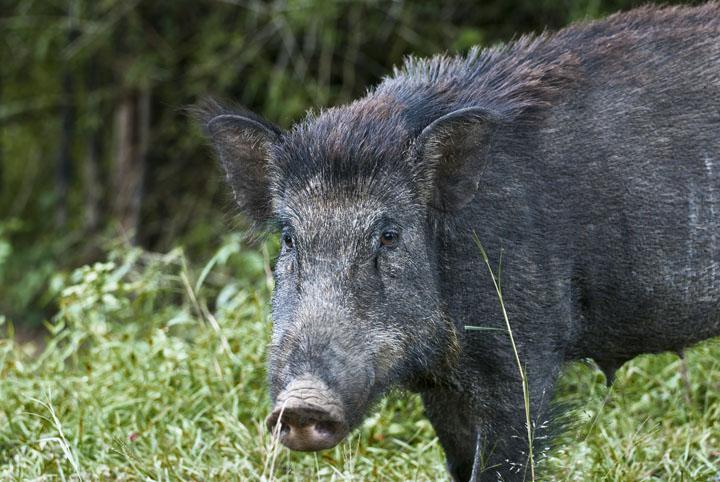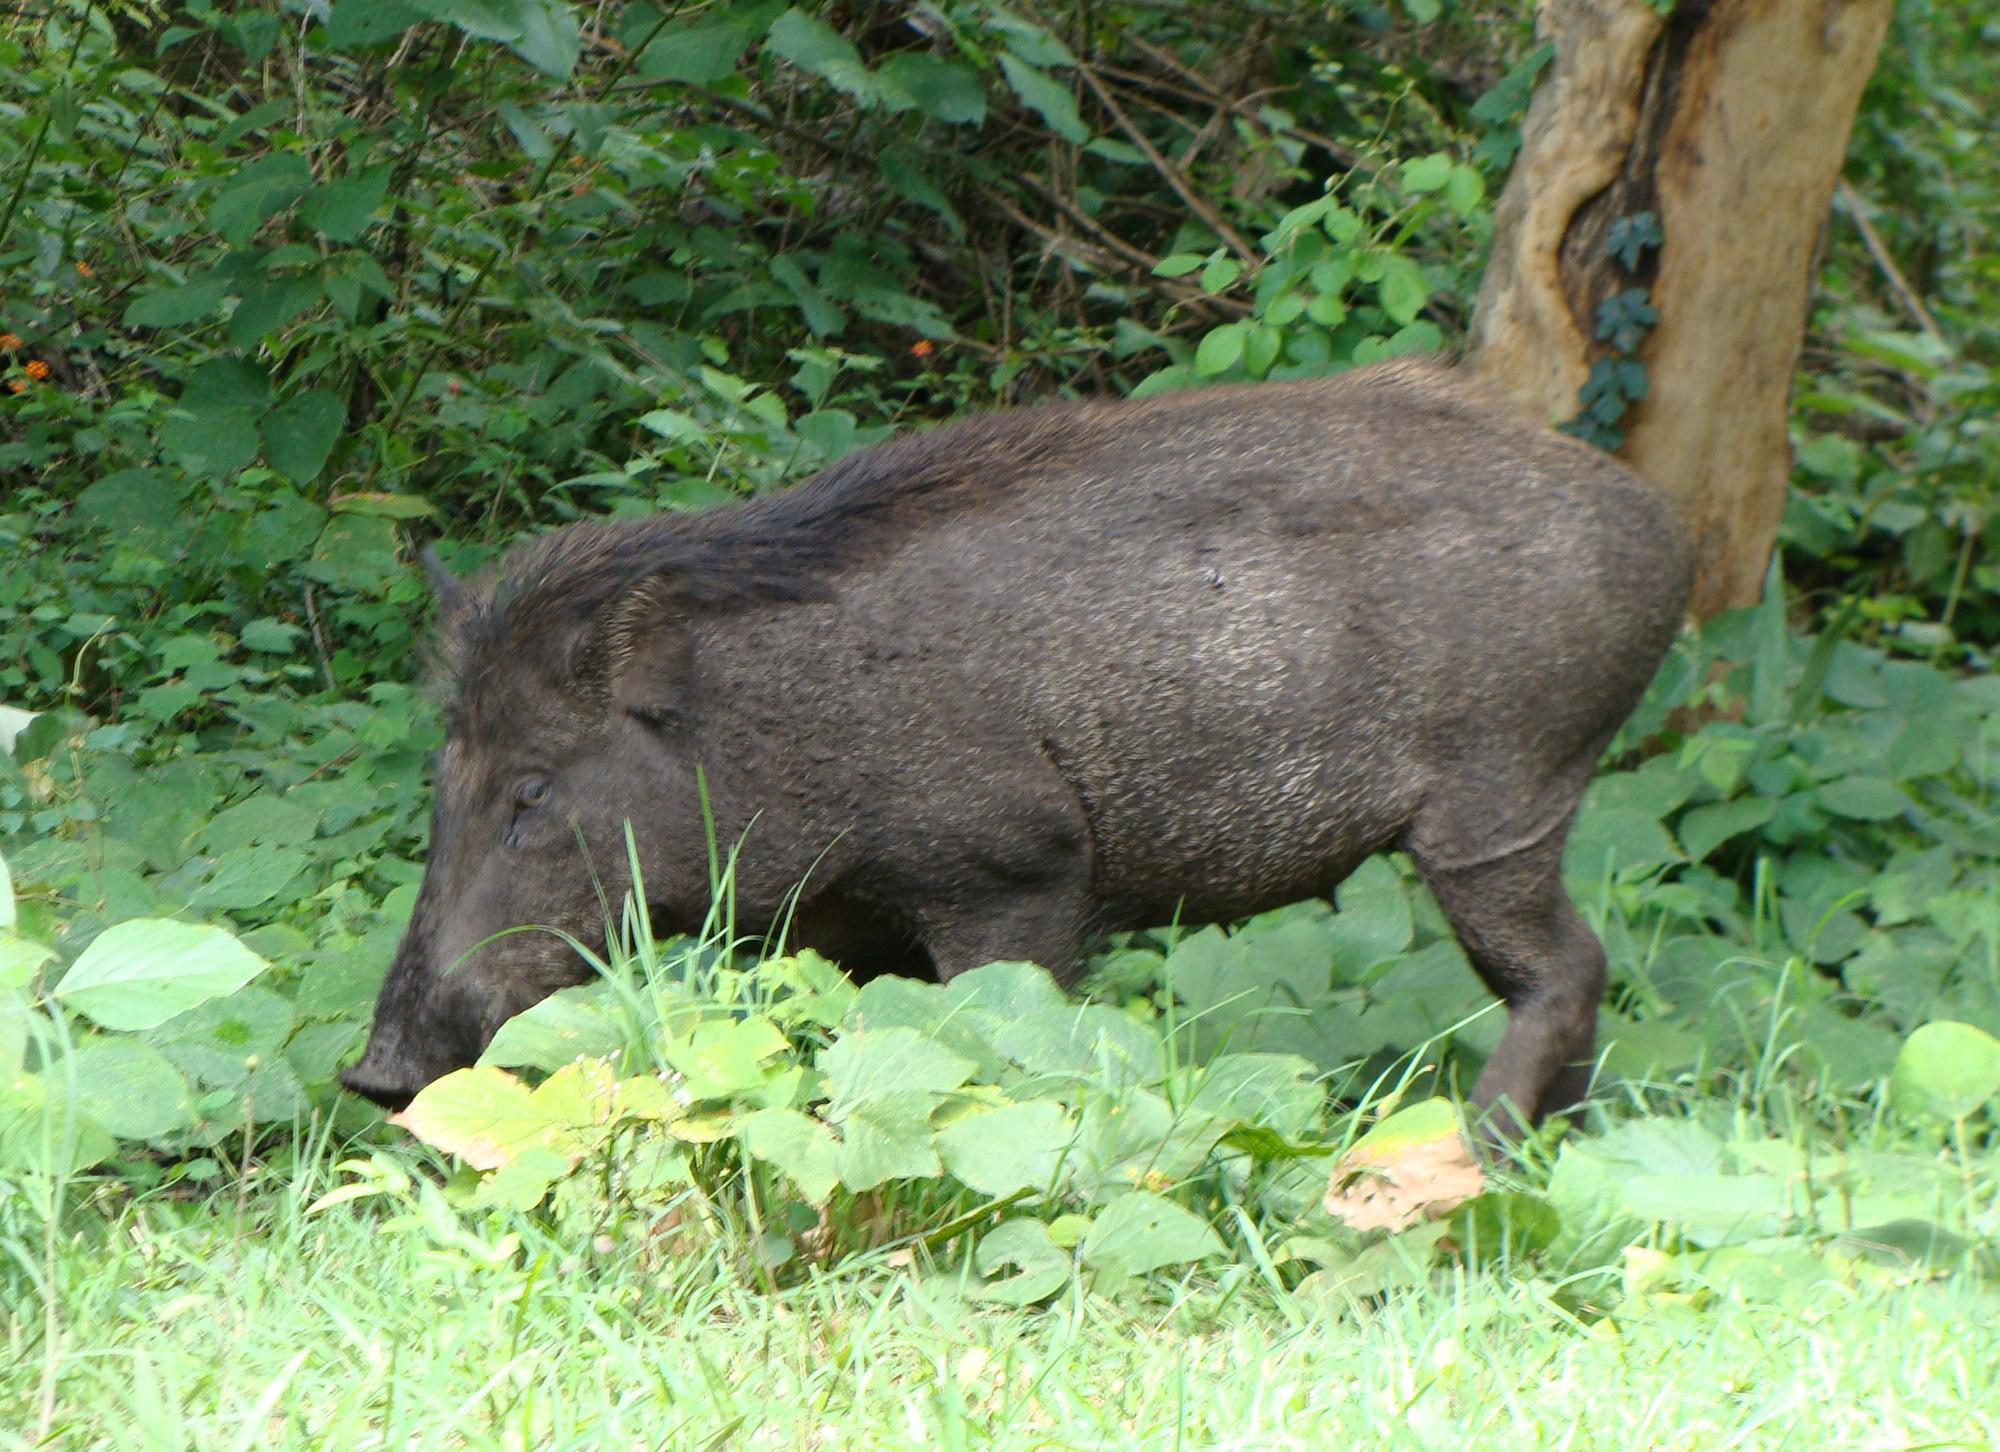The first image is the image on the left, the second image is the image on the right. Given the left and right images, does the statement "Both animals are standing in a field." hold true? Answer yes or no. Yes. The first image is the image on the left, the second image is the image on the right. Considering the images on both sides, is "The boar in the right image is standing in green foliage." valid? Answer yes or no. Yes. 